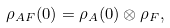<formula> <loc_0><loc_0><loc_500><loc_500>\rho _ { A F } ( 0 ) = \rho _ { A } ( 0 ) \otimes \rho _ { F } ,</formula> 